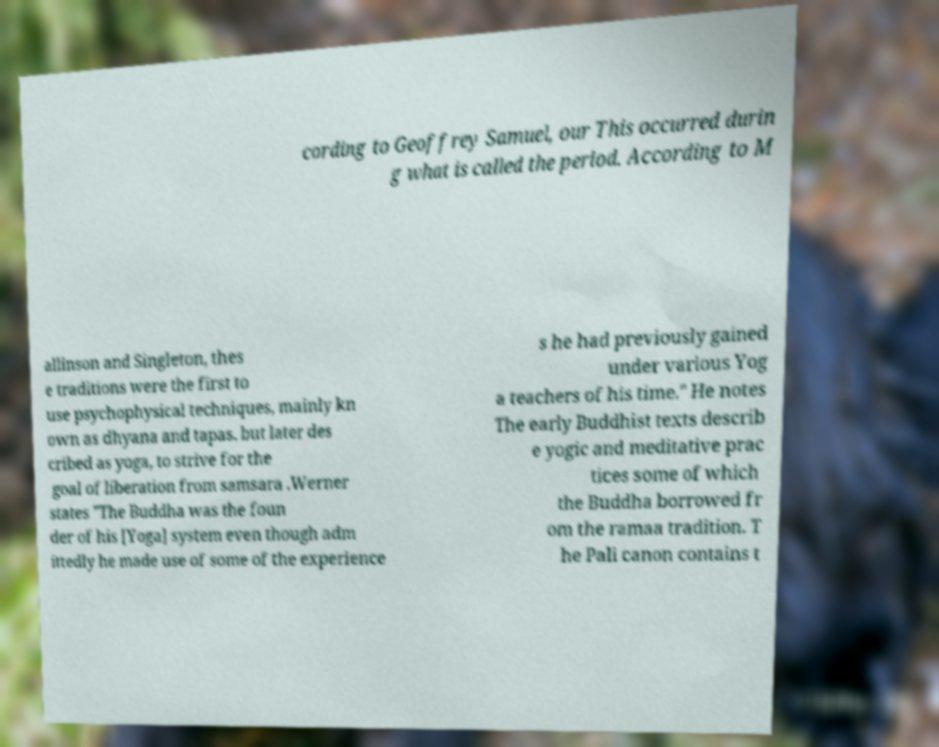Could you assist in decoding the text presented in this image and type it out clearly? cording to Geoffrey Samuel, our This occurred durin g what is called the period. According to M allinson and Singleton, thes e traditions were the first to use psychophysical techniques, mainly kn own as dhyana and tapas. but later des cribed as yoga, to strive for the goal of liberation from samsara .Werner states "The Buddha was the foun der of his [Yoga] system even though adm ittedly he made use of some of the experience s he had previously gained under various Yog a teachers of his time." He notes The early Buddhist texts describ e yogic and meditative prac tices some of which the Buddha borrowed fr om the ramaa tradition. T he Pali canon contains t 